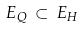Convert formula to latex. <formula><loc_0><loc_0><loc_500><loc_500>E _ { Q } \, \subset \, E _ { H }</formula> 